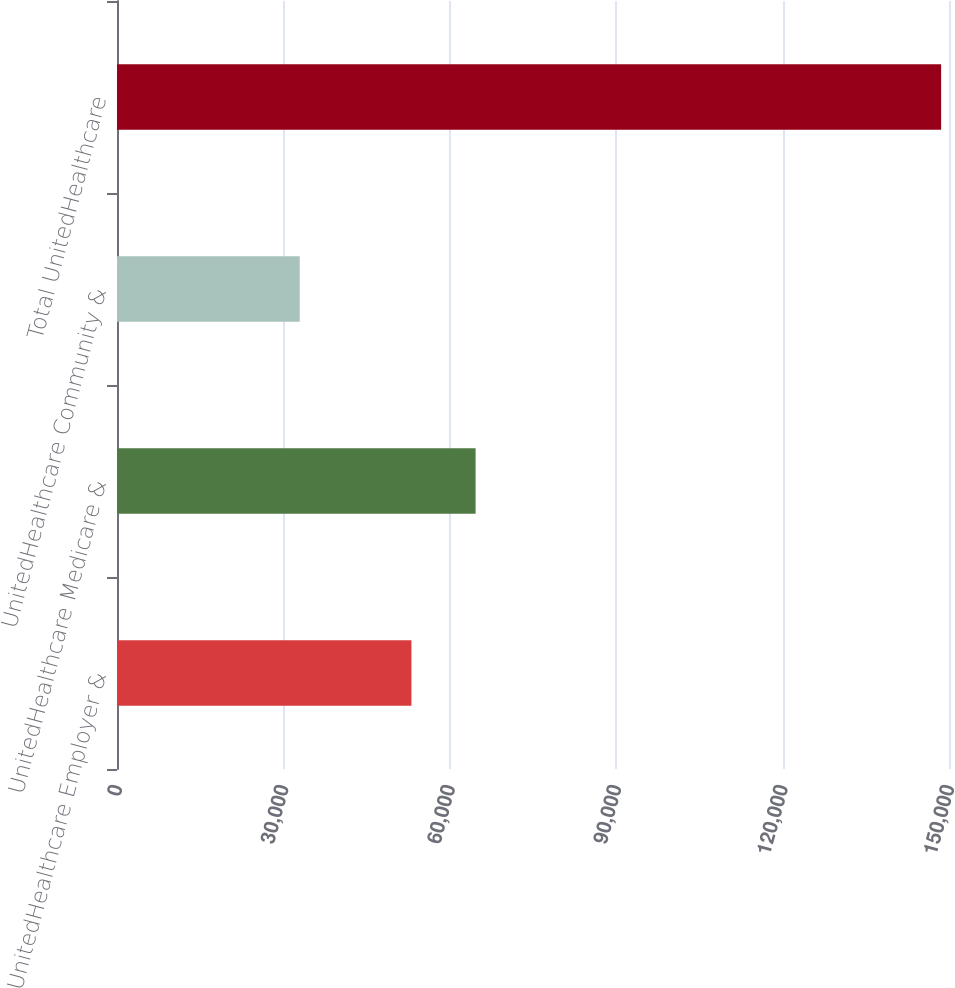<chart> <loc_0><loc_0><loc_500><loc_500><bar_chart><fcel>UnitedHealthcare Employer &<fcel>UnitedHealthcare Medicare &<fcel>UnitedHealthcare Community &<fcel>Total UnitedHealthcare<nl><fcel>53084<fcel>64647.6<fcel>32945<fcel>148581<nl></chart> 